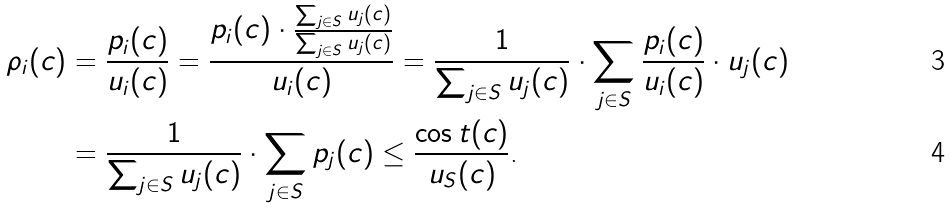Convert formula to latex. <formula><loc_0><loc_0><loc_500><loc_500>\rho _ { i } ( c ) & = \frac { p _ { i } ( c ) } { u _ { i } ( c ) } = \frac { p _ { i } ( c ) \cdot \frac { \sum _ { j \in S } u _ { j } ( c ) } { \sum _ { j \in S } u _ { j } ( c ) } } { u _ { i } ( c ) } = \frac { 1 } { \sum _ { j \in S } u _ { j } ( c ) } \cdot \sum _ { j \in S } \frac { p _ { i } ( c ) } { u _ { i } ( c ) } \cdot u _ { j } ( c ) \\ & = \frac { 1 } { \sum _ { j \in S } u _ { j } ( c ) } \cdot \sum _ { j \in S } p _ { j } ( c ) \leq \frac { \cos t ( c ) } { u _ { S } ( c ) } \text {.}</formula> 